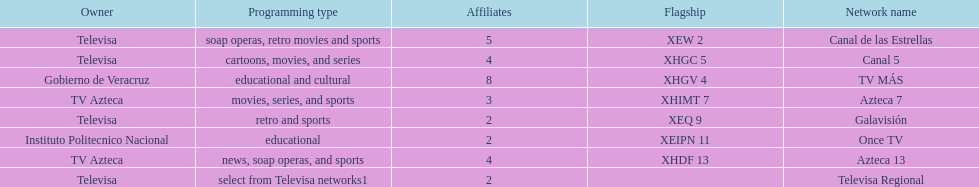What is the sole station that has 8 associated channels? TV MÁS. 